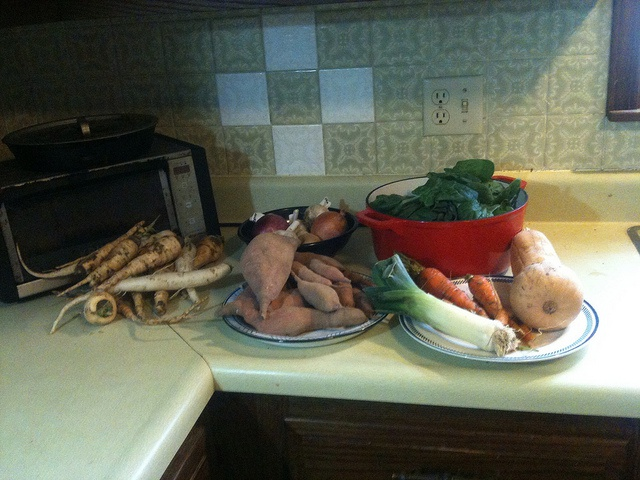Describe the objects in this image and their specific colors. I can see microwave in black, darkgreen, and gray tones, bowl in black, maroon, and darkgreen tones, carrot in black, brown, maroon, and salmon tones, bowl in black, gray, and darkgray tones, and carrot in black, maroon, brown, and gray tones in this image. 